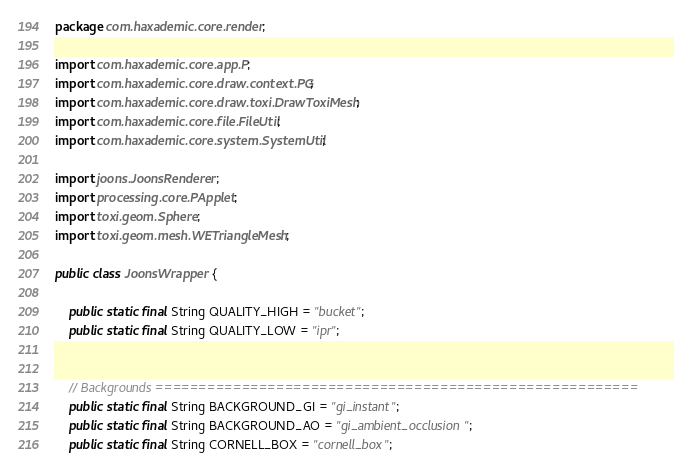Convert code to text. <code><loc_0><loc_0><loc_500><loc_500><_Java_>package com.haxademic.core.render;

import com.haxademic.core.app.P;
import com.haxademic.core.draw.context.PG;
import com.haxademic.core.draw.toxi.DrawToxiMesh;
import com.haxademic.core.file.FileUtil;
import com.haxademic.core.system.SystemUtil;

import joons.JoonsRenderer;
import processing.core.PApplet;
import toxi.geom.Sphere;
import toxi.geom.mesh.WETriangleMesh;

public class JoonsWrapper {

	public static final String QUALITY_HIGH = "bucket";
	public static final String QUALITY_LOW = "ipr";

	
	// Backgrounds ========================================================
	public static final String BACKGROUND_GI = "gi_instant";
	public static final String BACKGROUND_AO = "gi_ambient_occlusion";
	public static final String CORNELL_BOX = "cornell_box";</code> 